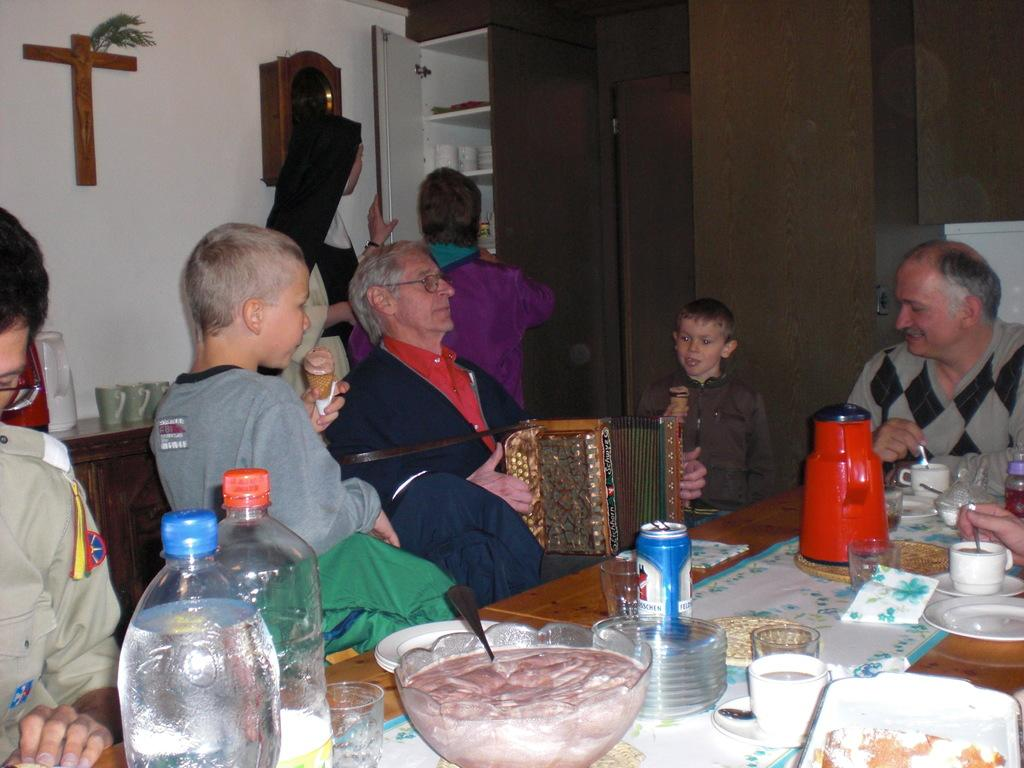Where was the image taken? The image was taken inside a house. What are the people in the image doing? The people are sitting at a dining table. What can be seen on the dining table? Food items are on the dining table. What color are the containers visible in the background? The containers in the background are brown. Are there any giants present in the image? No, there are no giants present in the image. What type of locket can be seen around the neck of the person sitting at the dining table? There is no locket visible around the neck of any person in the image. 